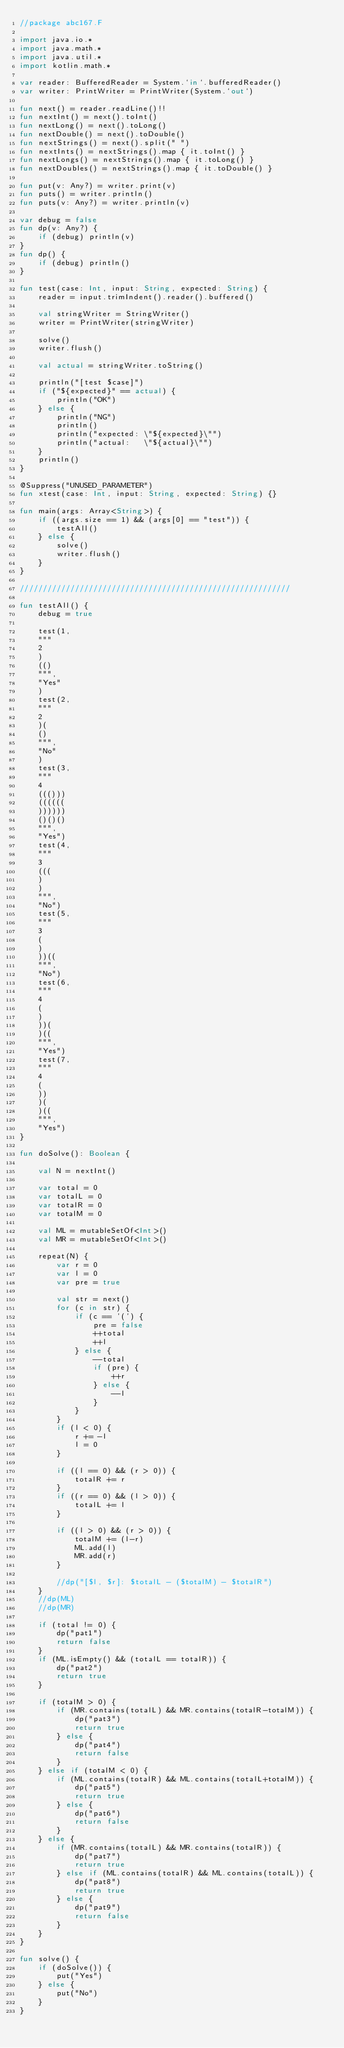<code> <loc_0><loc_0><loc_500><loc_500><_Kotlin_>//package abc167.F

import java.io.*
import java.math.*
import java.util.*
import kotlin.math.*

var reader: BufferedReader = System.`in`.bufferedReader()
var writer: PrintWriter = PrintWriter(System.`out`)

fun next() = reader.readLine()!!
fun nextInt() = next().toInt()
fun nextLong() = next().toLong()
fun nextDouble() = next().toDouble()
fun nextStrings() = next().split(" ")
fun nextInts() = nextStrings().map { it.toInt() }
fun nextLongs() = nextStrings().map { it.toLong() }
fun nextDoubles() = nextStrings().map { it.toDouble() }

fun put(v: Any?) = writer.print(v)
fun puts() = writer.println()
fun puts(v: Any?) = writer.println(v)

var debug = false
fun dp(v: Any?) {
    if (debug) println(v)
}
fun dp() {
    if (debug) println()
}

fun test(case: Int, input: String, expected: String) {
    reader = input.trimIndent().reader().buffered()

    val stringWriter = StringWriter()
    writer = PrintWriter(stringWriter)

    solve()
    writer.flush()

    val actual = stringWriter.toString()

    println("[test $case]")
    if ("${expected}" == actual) {
        println("OK")
    } else {
        println("NG")
        println()
        println("expected: \"${expected}\"")
        println("actual:   \"${actual}\"")
    }
    println()
}

@Suppress("UNUSED_PARAMETER")
fun xtest(case: Int, input: String, expected: String) {}

fun main(args: Array<String>) {
    if ((args.size == 1) && (args[0] == "test")) {
        testAll()
    } else {
        solve()
        writer.flush()
    }
}

///////////////////////////////////////////////////////////

fun testAll() {
    debug = true

    test(1,
    """
    2
    )
    (()
    """,
    "Yes"
    )
    test(2,
    """
    2
    )(
    ()
    """,
    "No"
    )
    test(3,
    """
    4
    ((()))
    ((((((
    ))))))
    ()()()
    """,
    "Yes")
    test(4,
    """
    3
    (((
    )
    )
    """,
    "No")
    test(5,
    """
    3
    (
    )
    ))((
    """,
    "No")
    test(6,
    """
    4
    (
    )
    ))(
    )((
    """,
    "Yes")
    test(7,
    """
    4
    (
    ))
    )(
    )((
    """,
    "Yes")
}

fun doSolve(): Boolean {

    val N = nextInt()

    var total = 0
    var totalL = 0
    var totalR = 0
    var totalM = 0

    val ML = mutableSetOf<Int>()
    val MR = mutableSetOf<Int>()

    repeat(N) {
        var r = 0
        var l = 0
        var pre = true

        val str = next()
        for (c in str) {
            if (c == '(') {
                pre = false
                ++total
                ++l
            } else {
                --total
                if (pre) {
                    ++r
                } else {
                    --l
                }
            }
        }
        if (l < 0) {
            r += -l
            l = 0
        }

        if ((l == 0) && (r > 0)) {
            totalR += r
        }
        if ((r == 0) && (l > 0)) {
            totalL += l
        }

        if ((l > 0) && (r > 0)) {
            totalM += (l-r)
            ML.add(l)
            MR.add(r)
        }

        //dp("[$l, $r]: $totalL - ($totalM) - $totalR")
    }
    //dp(ML)
    //dp(MR)

    if (total != 0) {
        dp("pat1")
        return false
    }
    if (ML.isEmpty() && (totalL == totalR)) {
        dp("pat2")
        return true
    }

    if (totalM > 0) {
        if (MR.contains(totalL) && MR.contains(totalR-totalM)) {
            dp("pat3")
            return true
        } else {
            dp("pat4")
            return false
        }
    } else if (totalM < 0) {
        if (ML.contains(totalR) && ML.contains(totalL+totalM)) {
            dp("pat5")
            return true
        } else {
            dp("pat6")
            return false
        }
    } else {
        if (MR.contains(totalL) && MR.contains(totalR)) {
            dp("pat7")
            return true
        } else if (ML.contains(totalR) && ML.contains(totalL)) {
            dp("pat8")
            return true
        } else {
            dp("pat9")
            return false
        }
    }
}

fun solve() {
    if (doSolve()) {
        put("Yes")
    } else {
        put("No")
    }
}
</code> 